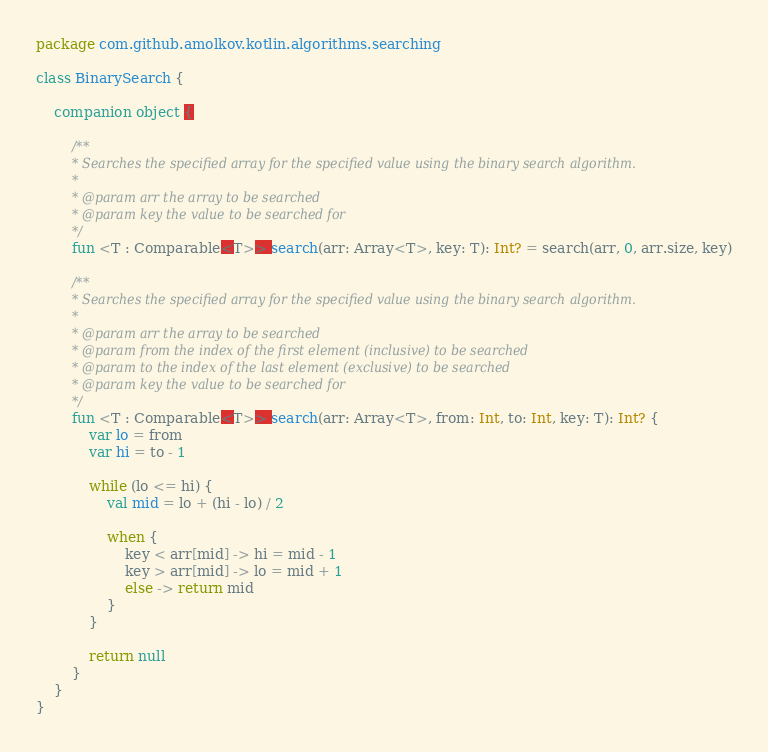<code> <loc_0><loc_0><loc_500><loc_500><_Kotlin_>package com.github.amolkov.kotlin.algorithms.searching

class BinarySearch {

    companion object {

        /**
         * Searches the specified array for the specified value using the binary search algorithm.
         *
         * @param arr the array to be searched
         * @param key the value to be searched for
         */
        fun <T : Comparable<T>> search(arr: Array<T>, key: T): Int? = search(arr, 0, arr.size, key)

        /**
         * Searches the specified array for the specified value using the binary search algorithm.
         *
         * @param arr the array to be searched
         * @param from the index of the first element (inclusive) to be searched
         * @param to the index of the last element (exclusive) to be searched
         * @param key the value to be searched for
         */
        fun <T : Comparable<T>> search(arr: Array<T>, from: Int, to: Int, key: T): Int? {
            var lo = from
            var hi = to - 1

            while (lo <= hi) {
                val mid = lo + (hi - lo) / 2

                when {
                    key < arr[mid] -> hi = mid - 1
                    key > arr[mid] -> lo = mid + 1
                    else -> return mid
                }
            }

            return null
        }
    }
}
</code> 